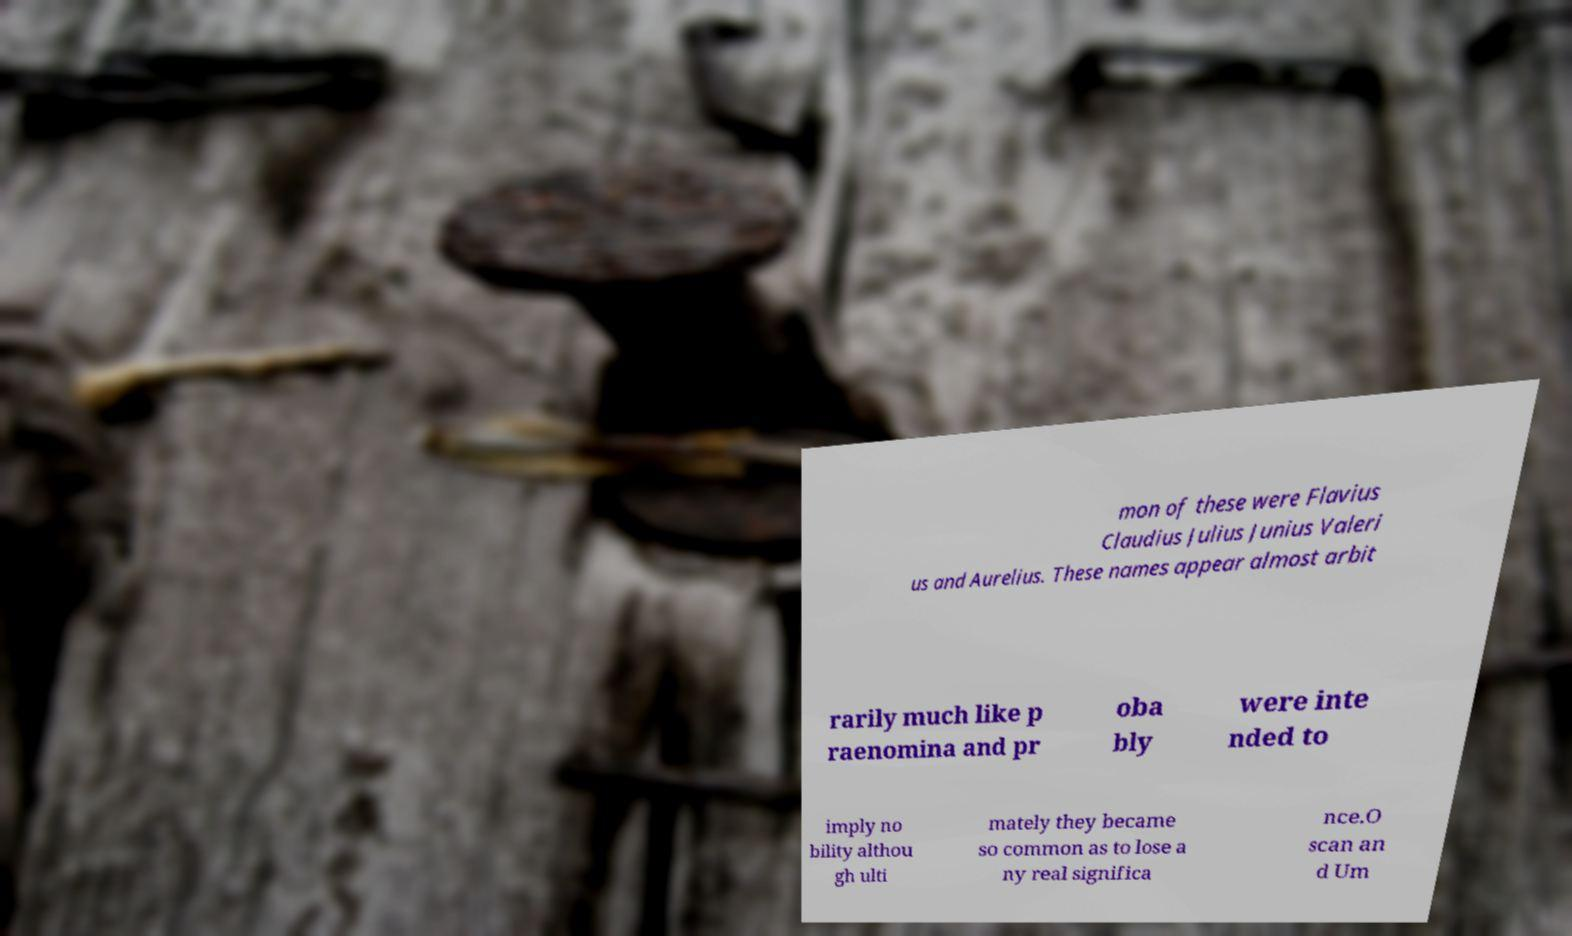Please identify and transcribe the text found in this image. mon of these were Flavius Claudius Julius Junius Valeri us and Aurelius. These names appear almost arbit rarily much like p raenomina and pr oba bly were inte nded to imply no bility althou gh ulti mately they became so common as to lose a ny real significa nce.O scan an d Um 